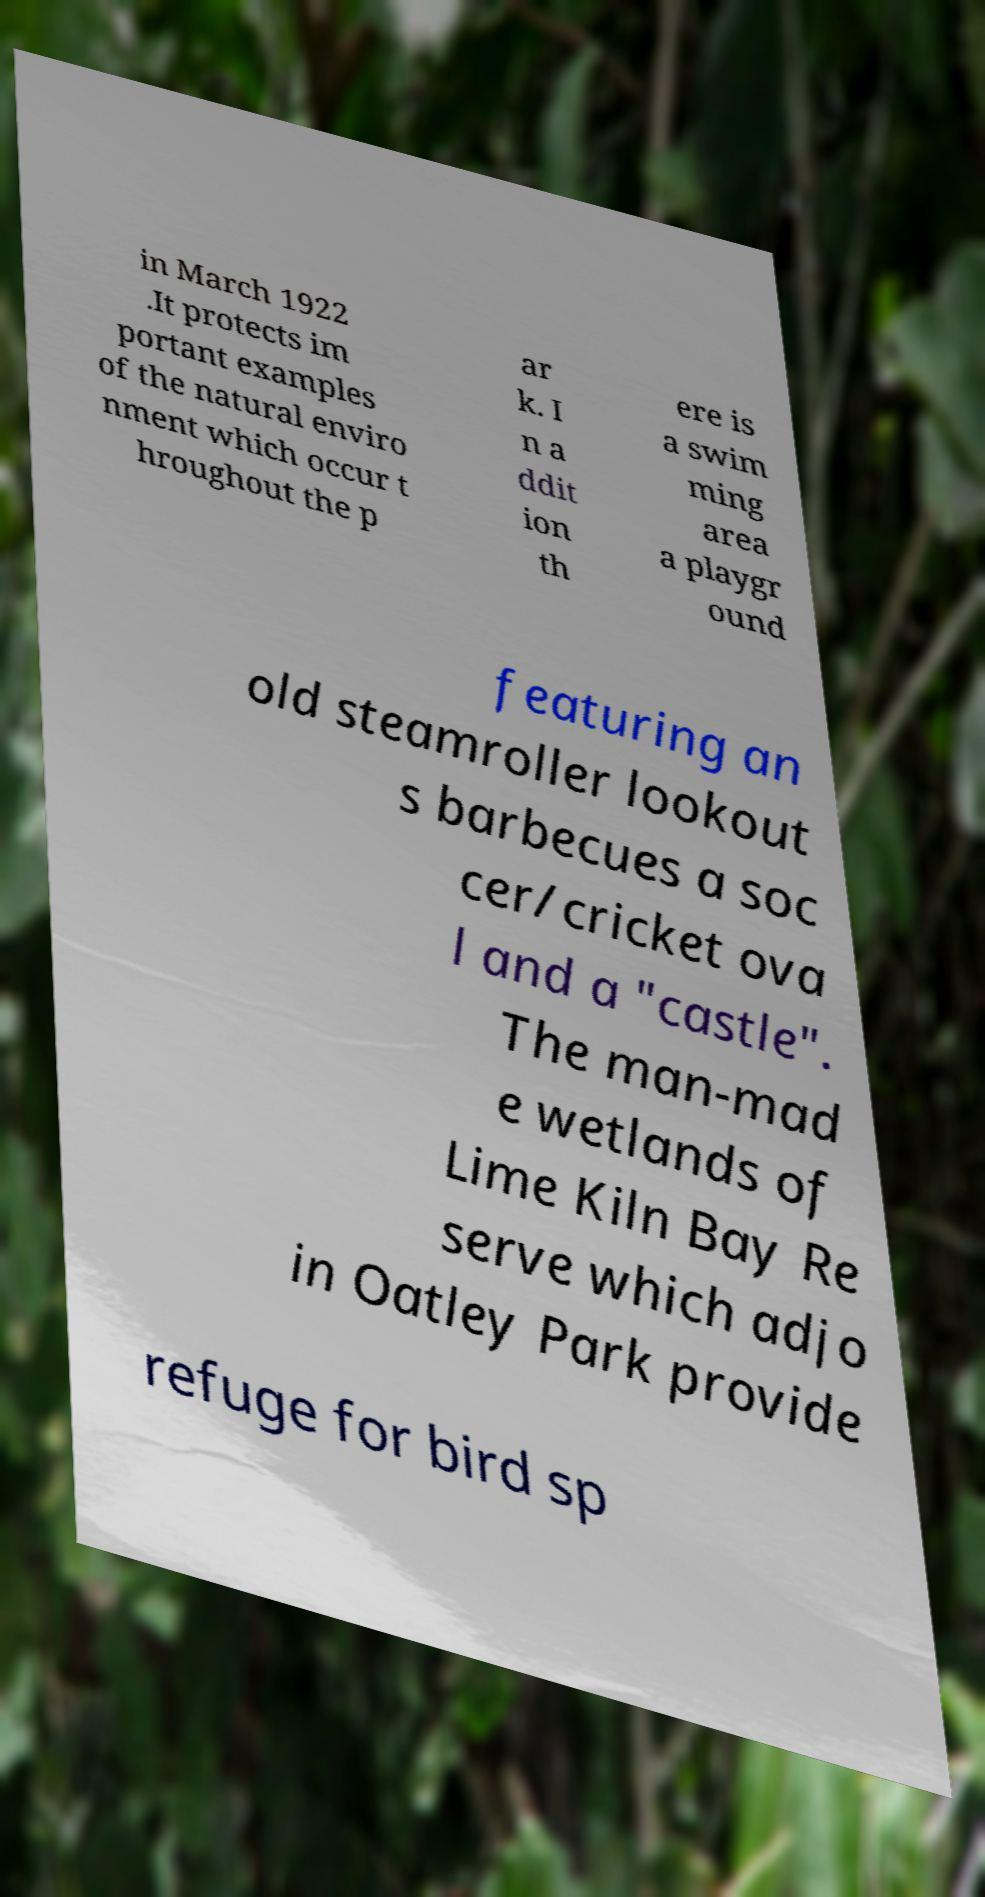What messages or text are displayed in this image? I need them in a readable, typed format. in March 1922 .It protects im portant examples of the natural enviro nment which occur t hroughout the p ar k. I n a ddit ion th ere is a swim ming area a playgr ound featuring an old steamroller lookout s barbecues a soc cer/cricket ova l and a "castle". The man-mad e wetlands of Lime Kiln Bay Re serve which adjo in Oatley Park provide refuge for bird sp 